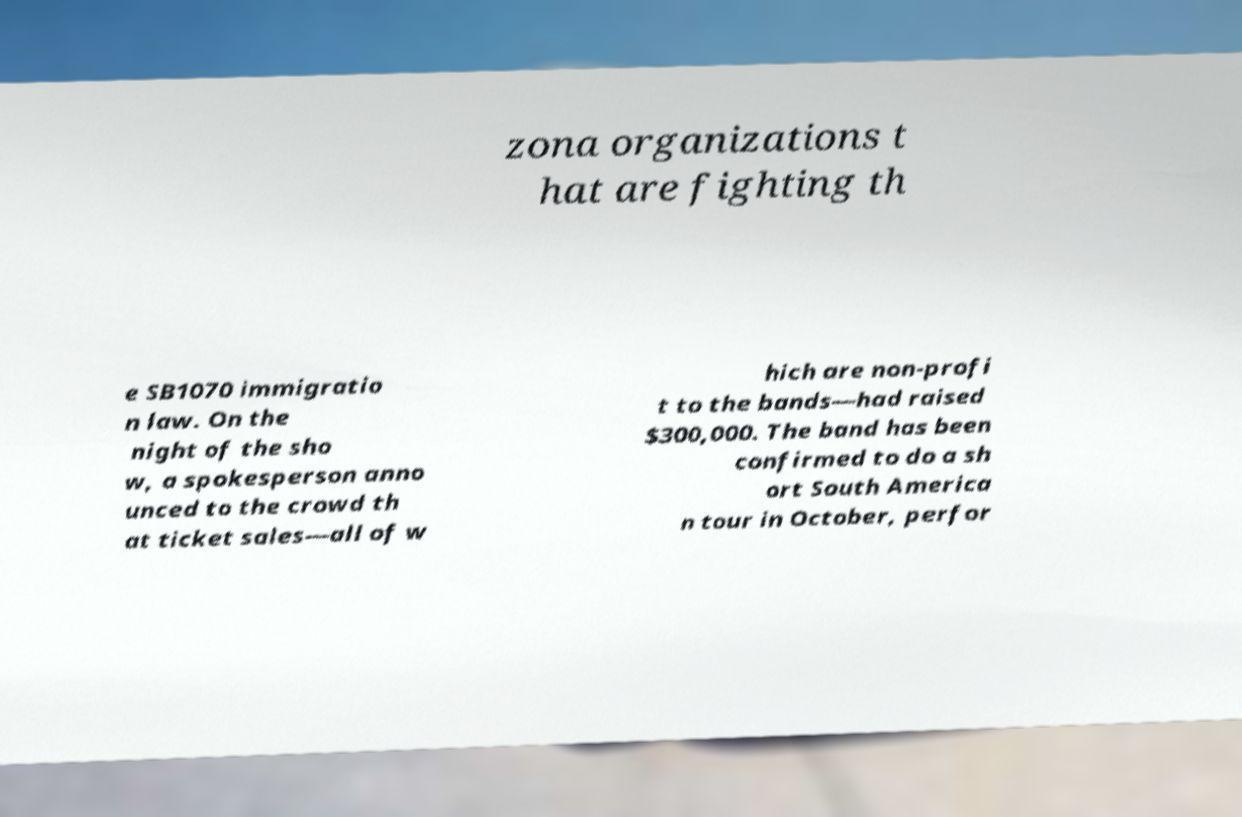For documentation purposes, I need the text within this image transcribed. Could you provide that? zona organizations t hat are fighting th e SB1070 immigratio n law. On the night of the sho w, a spokesperson anno unced to the crowd th at ticket sales—all of w hich are non-profi t to the bands—had raised $300,000. The band has been confirmed to do a sh ort South America n tour in October, perfor 